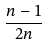Convert formula to latex. <formula><loc_0><loc_0><loc_500><loc_500>\frac { n - 1 } { 2 n }</formula> 